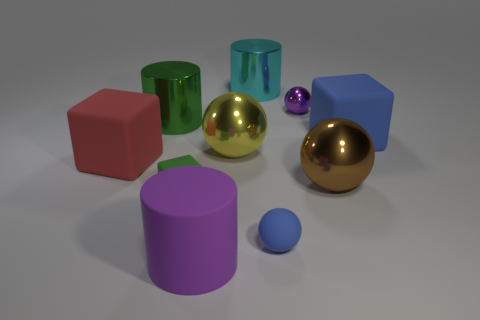Do the big matte cube to the left of the big blue matte object and the tiny metal thing have the same color?
Keep it short and to the point. No. There is a purple matte object that is the same shape as the big cyan metallic object; what size is it?
Keep it short and to the point. Large. How many objects are either objects that are in front of the small green rubber block or metal objects in front of the large blue rubber block?
Your answer should be very brief. 4. There is a purple object that is in front of the shiny thing that is left of the yellow metal thing; what shape is it?
Ensure brevity in your answer.  Cylinder. Is there anything else that is the same color as the small cube?
Offer a terse response. Yes. How many things are either matte things or big brown metal balls?
Your response must be concise. 6. Are there any red rubber cubes that have the same size as the yellow thing?
Provide a short and direct response. Yes. The yellow object has what shape?
Your response must be concise. Sphere. Is the number of large brown objects that are behind the big cyan thing greater than the number of big red matte things in front of the small green rubber thing?
Keep it short and to the point. No. Do the block that is right of the cyan cylinder and the tiny ball in front of the large blue rubber thing have the same color?
Offer a terse response. Yes. 